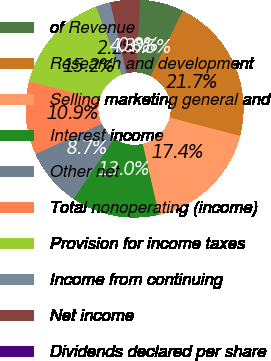Convert chart to OTSL. <chart><loc_0><loc_0><loc_500><loc_500><pie_chart><fcel>of Revenue<fcel>Research and development<fcel>Selling marketing general and<fcel>Interest income<fcel>Other net<fcel>Total nonoperating (income)<fcel>Provision for income taxes<fcel>Income from continuing<fcel>Net income<fcel>Dividends declared per share<nl><fcel>6.52%<fcel>21.74%<fcel>17.39%<fcel>13.04%<fcel>8.7%<fcel>10.87%<fcel>15.22%<fcel>2.17%<fcel>4.35%<fcel>0.0%<nl></chart> 